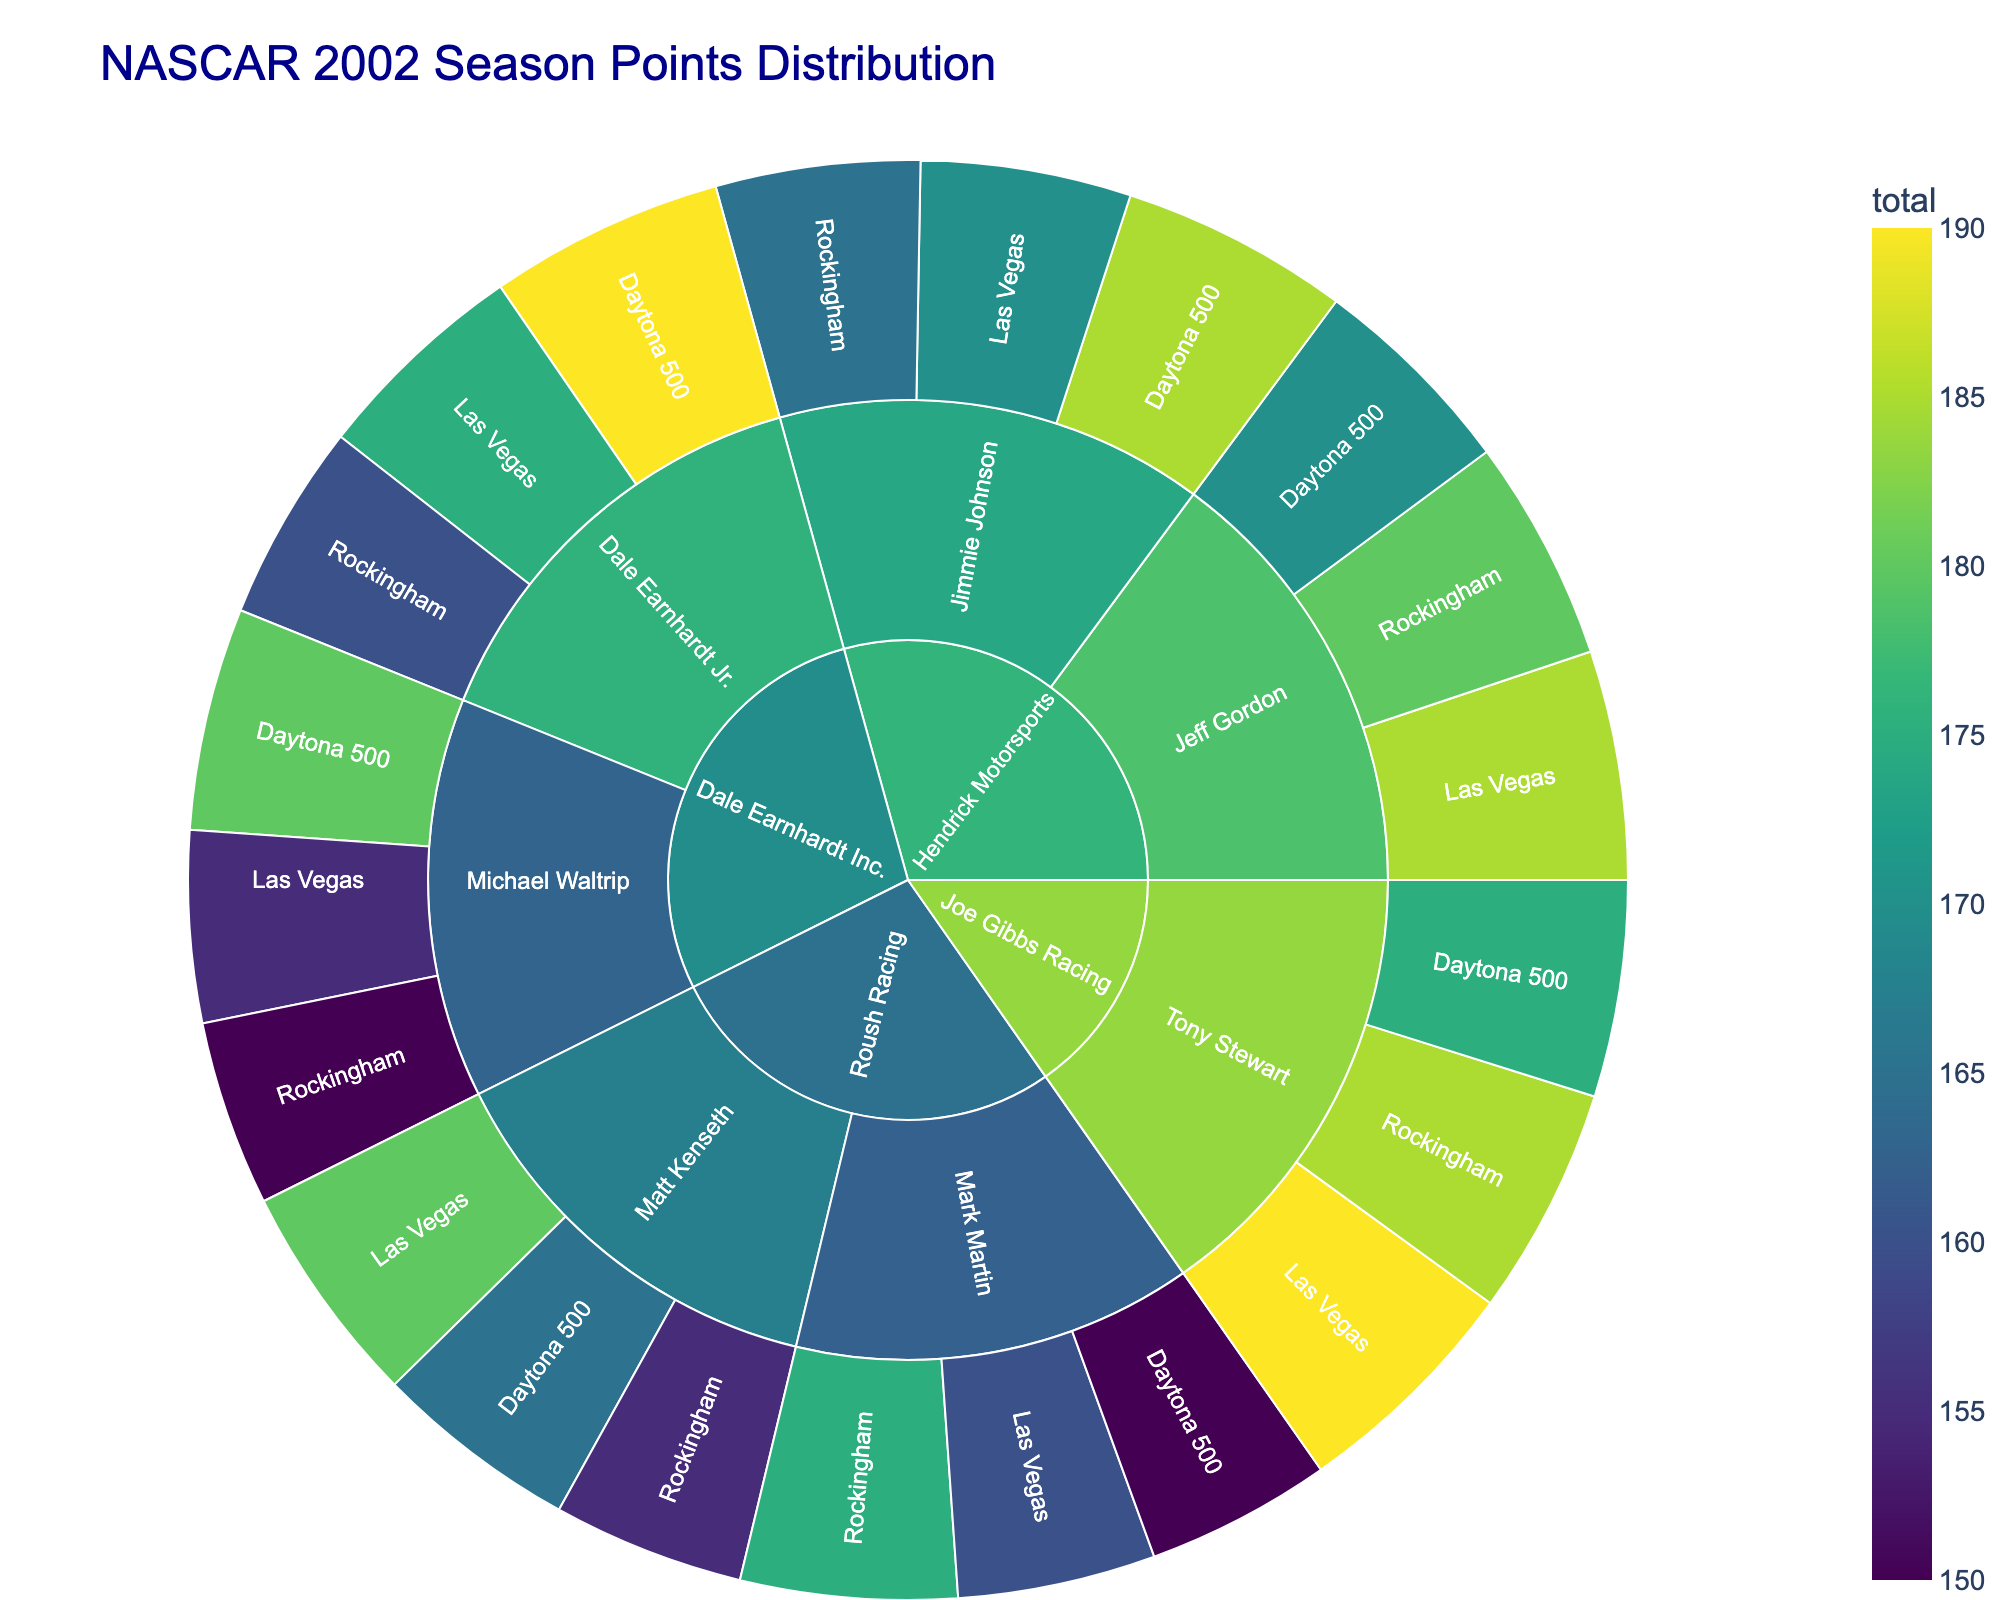What's the total number of points Jimmie Johnson earned in the Daytona 500 race? Refer to the sector for Hendrick Motorsports, Jimmie Johnson, and Daytona 500. It shows 185 points
Answer: 185 Which team has Jeff Gordon as one of its drivers? Locate Jeff Gordon in the sunburst plot, and note the higher-level category it's under, which is Hendrick Motorsports
Answer: Hendrick Motorsports How many total points did drivers from Dale Earnhardt Inc. earn in the Daytona 500? Identify the Daytona 500 segments for both Dale Earnhardt Jr. and Michael Waltrip under Dale Earnhardt Inc., which are 190 and 180 respectively, then sum them up
Answer: 370 Which driver scored the most points in Las Vegas and how many? Look at all drivers under each team that participated in the Las Vegas race; Tony Stewart's segment shows 190 points
Answer: Tony Stewart, 190 Between Jeff Gordon and Tony Stewart, who scored more points in the Rockingham race? Compare the sectors for Jeff Gordon and Tony Stewart in the Rockingham race; Jeff Gordon has 180 points, and Tony Stewart has 185 points
Answer: Tony Stewart How many points did Mark Martin score in total for all three races? Sum up the points for Mark Martin in Daytona 500 (150), Rockingham (175), and Las Vegas (160): 150 + 175 + 160
Answer: 485 Which driver from Hendrick Motorsports scored the highest points in any race? Check the individual race sectors for drivers under Hendrick Motorsports; Jeff Gordon scored 185 points in Las Vegas
Answer: Jeff Gordon What's the color range of the plot indicating about the points distribution? The plot uses a viridis color scale, which typically ranges from dark blue (lower points) to yellow (higher points); it highlights different total points values
Answer: Points distribution Compare the points scored by Matt Kenseth and Michael Waltrip in Rockingham. Who has more? Check the sectors for Matt Kenseth and Michael Waltrip under Rockingham; Matt Kenseth scored 155 and Michael Waltrip scored 150
Answer: Matt Kenseth Which driver scored the least points in the Daytona 500 among all teams? Identify the points for all drivers in Daytona 500; Mark Martin has 150 points, the least among all
Answer: Mark Martin 